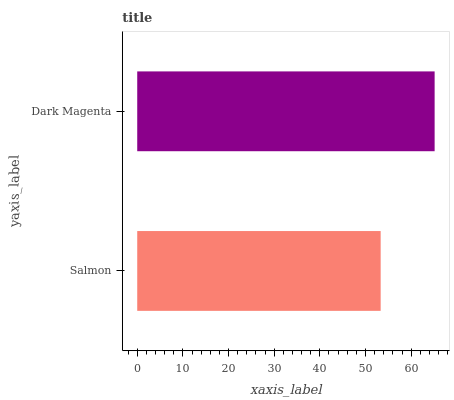Is Salmon the minimum?
Answer yes or no. Yes. Is Dark Magenta the maximum?
Answer yes or no. Yes. Is Dark Magenta the minimum?
Answer yes or no. No. Is Dark Magenta greater than Salmon?
Answer yes or no. Yes. Is Salmon less than Dark Magenta?
Answer yes or no. Yes. Is Salmon greater than Dark Magenta?
Answer yes or no. No. Is Dark Magenta less than Salmon?
Answer yes or no. No. Is Dark Magenta the high median?
Answer yes or no. Yes. Is Salmon the low median?
Answer yes or no. Yes. Is Salmon the high median?
Answer yes or no. No. Is Dark Magenta the low median?
Answer yes or no. No. 